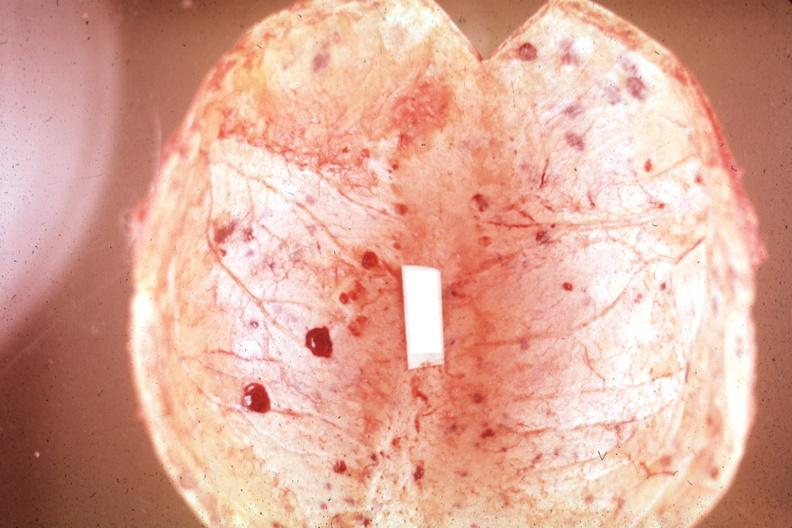s joints present?
Answer the question using a single word or phrase. Yes 